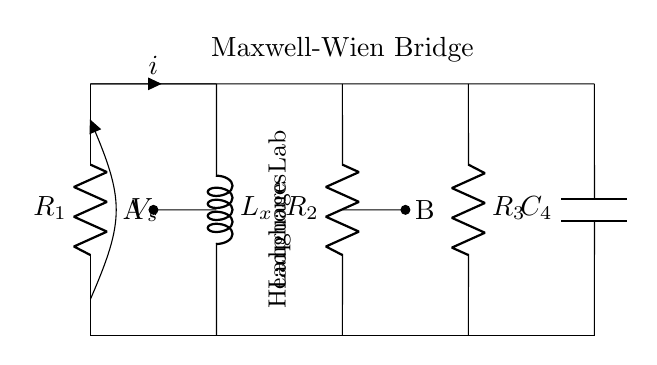What are the components in this circuit? The circuit consists of resistors R1, R2, and R3, an inductor Lx, and a capacitor C4. These elements are connected in a specific arrangement to form the Maxwell-Wien bridge.
Answer: R1, R2, R3, Lx, C4 What is the purpose of the Lx component? Lx is the inductor whose inductance will be determined using the Maxwell-Wien bridge method. It is placed in series with part of the circuit to help measure its own inductance.
Answer: To measure inductance How many resistors are in this circuit? The circuit has three resistors: R1, R2, and R3. These resistors form part of the bridge, which balances the circuit for measurements.
Answer: Three What is the voltage source in this circuit? The voltage source in this circuit is labeled as V_s, which provides the potential difference needed for the circuit to function and measure the inductance.
Answer: V_s What is the significance of points A and B in the circuit? Points A and B are the junctions where the measurement is taken to determine the balance of the bridge. They play a crucial role in analyzing the circuit for the unknown inductance by comparing voltage levels.
Answer: Measurement points How does the capacitor C4 interact with the resistors in this bridge? Capacitor C4 interacts with the resistors to create a frequency-dependent response in the circuit, contributing to the overall impedance which helps achieve balance in the bridge for precise inductance measurement.
Answer: Creates frequency response What can you infer about the circuit's balancing conditions? The balancing condition of a Maxwell-Wien bridge occurs when the ratios of the resistances R1 and R2 equal the ratio of the reactance of Lx and C4, leading to no current flowing through the detector between points A and B.
Answer: Balance achieved when ratios equal 